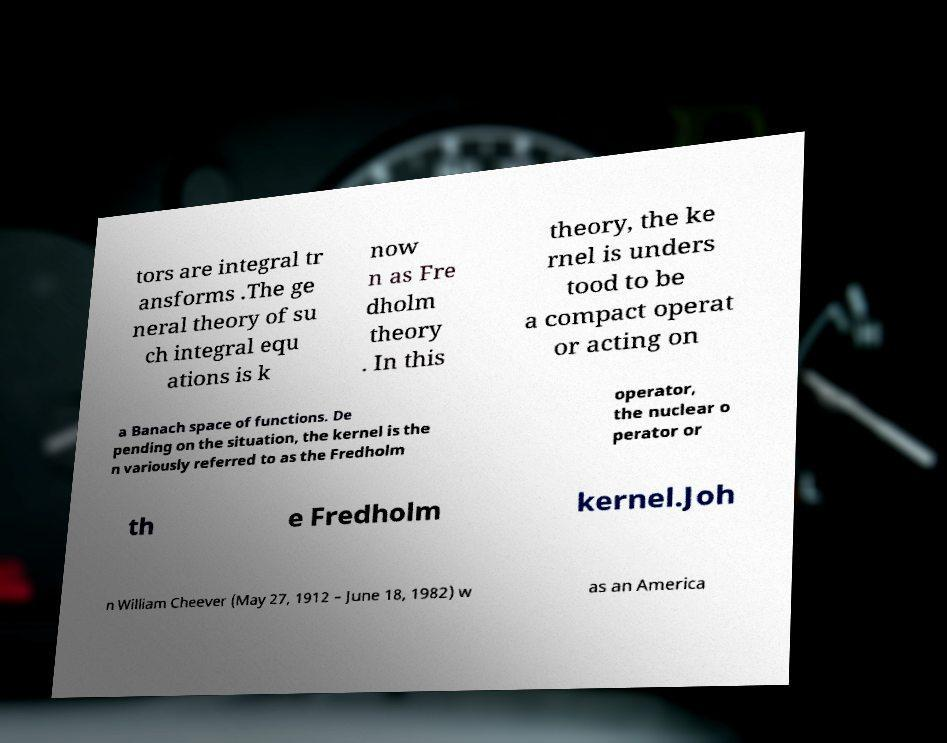Can you read and provide the text displayed in the image?This photo seems to have some interesting text. Can you extract and type it out for me? tors are integral tr ansforms .The ge neral theory of su ch integral equ ations is k now n as Fre dholm theory . In this theory, the ke rnel is unders tood to be a compact operat or acting on a Banach space of functions. De pending on the situation, the kernel is the n variously referred to as the Fredholm operator, the nuclear o perator or th e Fredholm kernel.Joh n William Cheever (May 27, 1912 – June 18, 1982) w as an America 